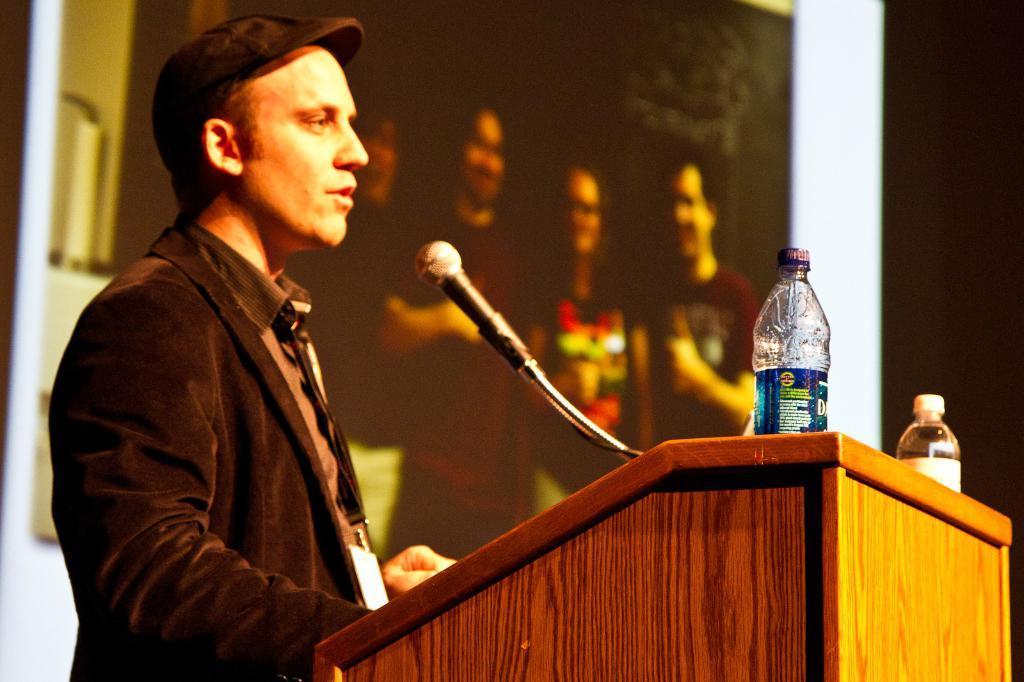Please provide a concise description of this image. In this image there is a person wearing black color suit standing behind the wooden block on which there is a microphone and water bottles. 